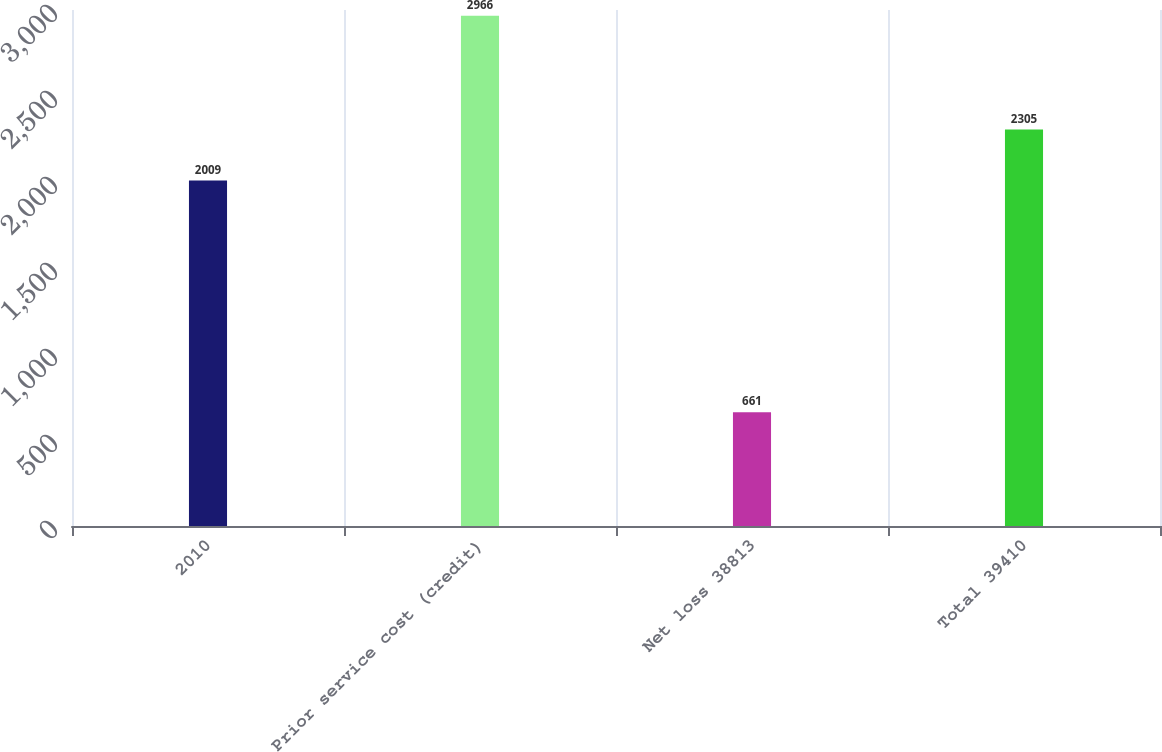<chart> <loc_0><loc_0><loc_500><loc_500><bar_chart><fcel>2010<fcel>Prior service cost (credit)<fcel>Net loss 38813<fcel>Total 39410<nl><fcel>2009<fcel>2966<fcel>661<fcel>2305<nl></chart> 